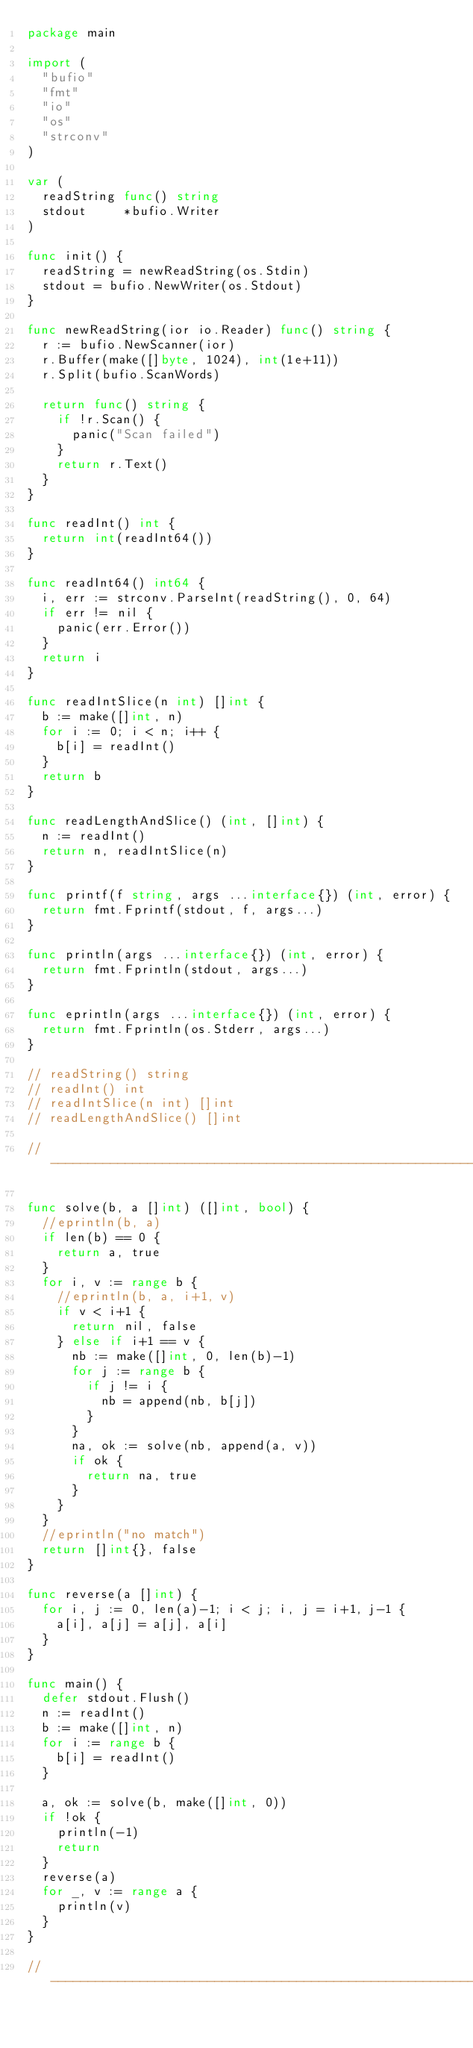<code> <loc_0><loc_0><loc_500><loc_500><_Go_>package main

import (
	"bufio"
	"fmt"
	"io"
	"os"
	"strconv"
)

var (
	readString func() string
	stdout     *bufio.Writer
)

func init() {
	readString = newReadString(os.Stdin)
	stdout = bufio.NewWriter(os.Stdout)
}

func newReadString(ior io.Reader) func() string {
	r := bufio.NewScanner(ior)
	r.Buffer(make([]byte, 1024), int(1e+11))
	r.Split(bufio.ScanWords)

	return func() string {
		if !r.Scan() {
			panic("Scan failed")
		}
		return r.Text()
	}
}

func readInt() int {
	return int(readInt64())
}

func readInt64() int64 {
	i, err := strconv.ParseInt(readString(), 0, 64)
	if err != nil {
		panic(err.Error())
	}
	return i
}

func readIntSlice(n int) []int {
	b := make([]int, n)
	for i := 0; i < n; i++ {
		b[i] = readInt()
	}
	return b
}

func readLengthAndSlice() (int, []int) {
	n := readInt()
	return n, readIntSlice(n)
}

func printf(f string, args ...interface{}) (int, error) {
	return fmt.Fprintf(stdout, f, args...)
}

func println(args ...interface{}) (int, error) {
	return fmt.Fprintln(stdout, args...)
}

func eprintln(args ...interface{}) (int, error) {
	return fmt.Fprintln(os.Stderr, args...)
}

// readString() string
// readInt() int
// readIntSlice(n int) []int
// readLengthAndSlice() []int

// -----------------------------------------------------------------------------

func solve(b, a []int) ([]int, bool) {
	//eprintln(b, a)
	if len(b) == 0 {
		return a, true
	}
	for i, v := range b {
		//eprintln(b, a, i+1, v)
		if v < i+1 {
			return nil, false
		} else if i+1 == v {
			nb := make([]int, 0, len(b)-1)
			for j := range b {
				if j != i {
					nb = append(nb, b[j])
				}
			}
			na, ok := solve(nb, append(a, v))
			if ok {
				return na, true
			}
		}
	}
	//eprintln("no match")
	return []int{}, false
}

func reverse(a []int) {
	for i, j := 0, len(a)-1; i < j; i, j = i+1, j-1 {
		a[i], a[j] = a[j], a[i]
	}
}

func main() {
	defer stdout.Flush()
	n := readInt()
	b := make([]int, n)
	for i := range b {
		b[i] = readInt()
	}

	a, ok := solve(b, make([]int, 0))
	if !ok {
		println(-1)
		return
	}
	reverse(a)
	for _, v := range a {
		println(v)
	}
}

// -----------------------------------------------------------------------------
</code> 